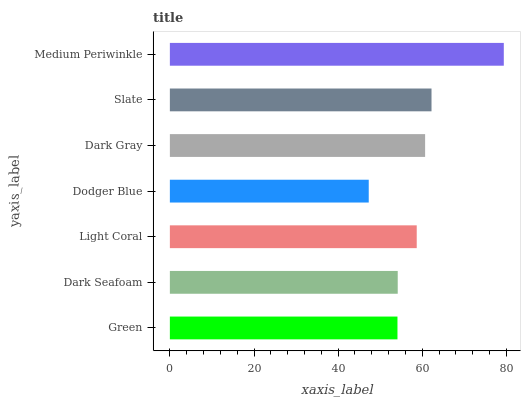Is Dodger Blue the minimum?
Answer yes or no. Yes. Is Medium Periwinkle the maximum?
Answer yes or no. Yes. Is Dark Seafoam the minimum?
Answer yes or no. No. Is Dark Seafoam the maximum?
Answer yes or no. No. Is Dark Seafoam greater than Green?
Answer yes or no. Yes. Is Green less than Dark Seafoam?
Answer yes or no. Yes. Is Green greater than Dark Seafoam?
Answer yes or no. No. Is Dark Seafoam less than Green?
Answer yes or no. No. Is Light Coral the high median?
Answer yes or no. Yes. Is Light Coral the low median?
Answer yes or no. Yes. Is Slate the high median?
Answer yes or no. No. Is Dark Seafoam the low median?
Answer yes or no. No. 